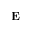<formula> <loc_0><loc_0><loc_500><loc_500>E</formula> 